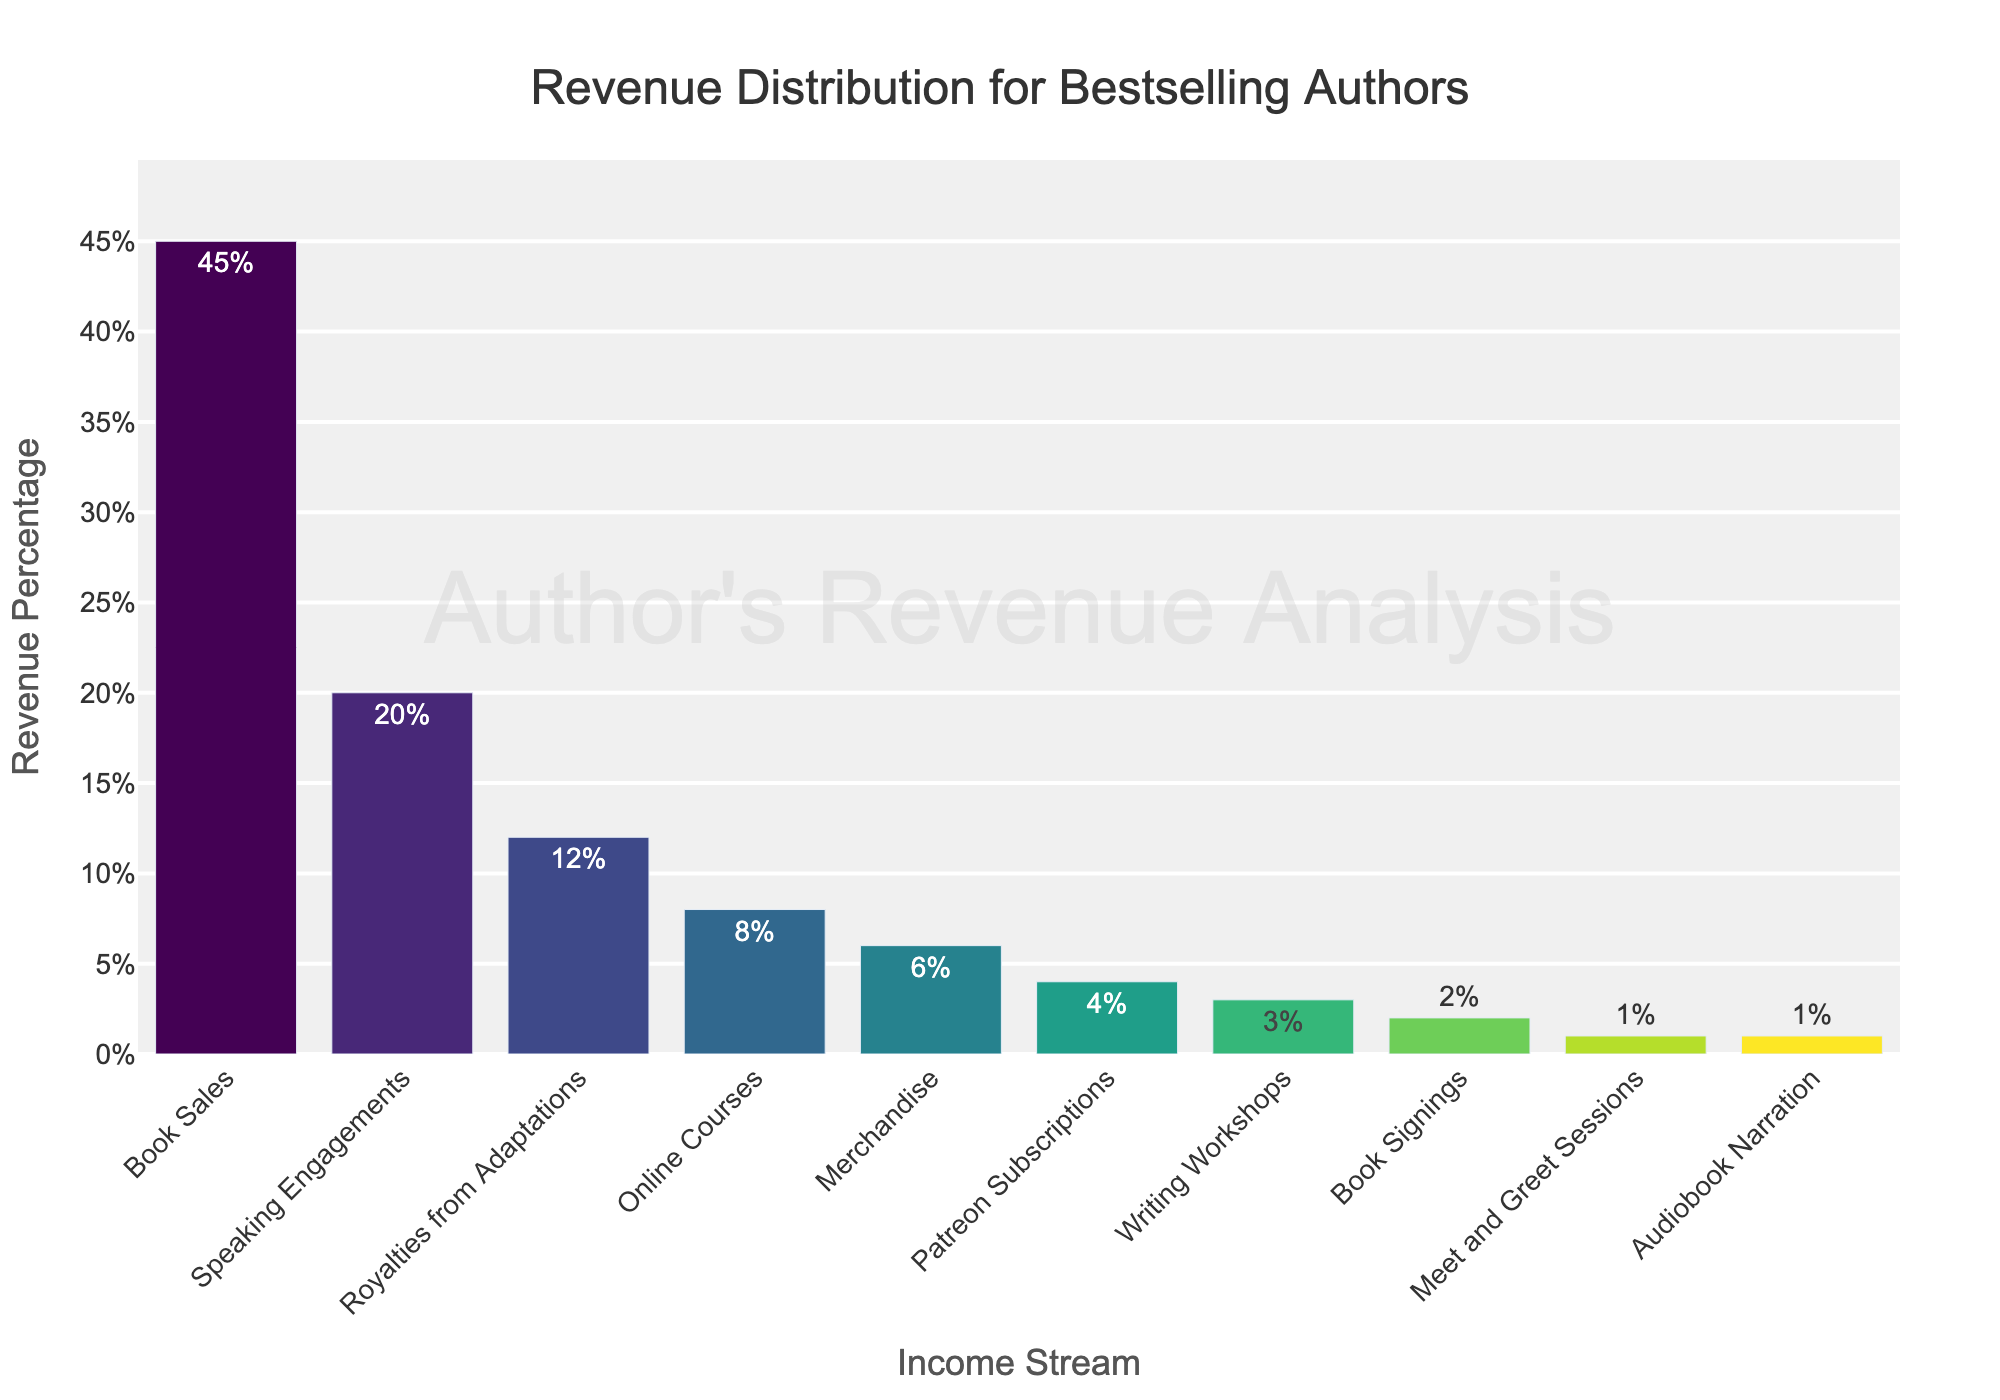Which income stream contributes the highest percentage to the revenue? By examining the bar chart, the bar representing 'Book Sales' is the highest, indicating that it contributes the highest percentage.
Answer: Book Sales What is the combined revenue percentage from 'Speaking Engagements' and 'Royalties from Adaptations'? The revenue percentage for 'Speaking Engagements' is 20%, and for 'Royalties from Adaptations' it is 12%. Adding these together: 20% + 12% = 32%.
Answer: 32% How does 'Online Courses' revenue compare to 'Merchandise' revenue? Comparing the heights of the bars for 'Online Courses' and 'Merchandise', 'Online Courses' (8%) contributes more to the revenue than 'Merchandise' (6%).
Answer: 'Online Courses' contributes more What is the average revenue percentage of 'Patreon Subscriptions', 'Writing Workshops', and 'Book Signings'? The revenue percentages are: 4% (Patreon Subscriptions), 3% (Writing Workshops), and 2% (Book Signings). The average is calculated as (4 + 3 + 2) / 3 = 3%.
Answer: 3% Which income streams contribute less than or equal to 3% of the revenue and how many are they? Bars representing 'Writing Workshops' (3%), 'Book Signings' (2%), 'Meet and Greet Sessions' (1%), and 'Audiobook Narration' (1%) all fall at or below 3%. There are four streams.
Answer: Writing Workshops, Book Signings, Meet and Greet Sessions, Audiobook Narration; Four By how much does the revenue from 'Book Sales' exceed that from 'Online Courses'? The revenue from 'Book Sales' is 45%, and from 'Online Courses' is 8%. The difference is calculated as 45% - 8% = 37%.
Answer: 37% What is the total revenue percentage from all income streams represented in the chart? Summing all the individual percentages: 45% (Book Sales) + 20% (Speaking Engagements) + 12% (Royalties from Adaptations) + 8% (Online Courses) + 6% (Merchandise) + 4% (Patreon Subscriptions) + 3% (Writing Workshops) + 2% (Book Signings) + 1% (Meet and Greet Sessions) + 1% (Audiobook Narration) = 100%.
Answer: 100% Rank the income streams by their revenue contribution from highest to lowest. Observing the bar chart, the order is: 
1. Book Sales (45%)
2. Speaking Engagements (20%)
3. Royalties from Adaptations (12%)
4. Online Courses (8%)
5. Merchandise (6%)
6. Patreon Subscriptions (4%)
7. Writing Workshops (3%)
8. Book Signings (2%)
9. Meet and Greet Sessions (1%)
10. Audiobook Narration (1%)
Answer: Book Sales > Speaking Engagements > Royalties from Adaptations > Online Courses > Merchandise > Patreon Subscriptions > Writing Workshops > Book Signings > Meet and Greet Sessions = Audiobook Narration What's the difference in percentage points between the highest and lowest revenue streams? The highest revenue stream is 'Book Sales' at 45%, and the lowest is shared by 'Meet and Greet Sessions' and 'Audiobook Narration' at 1%. The difference is 45% - 1% = 44%.
Answer: 44% 